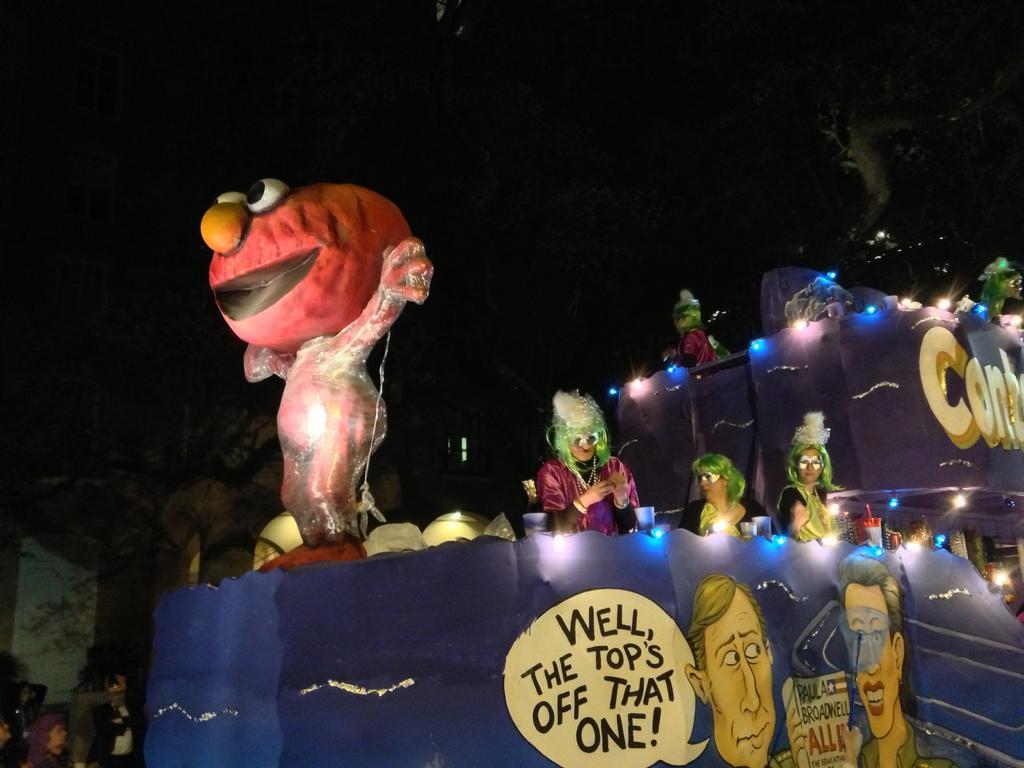Could you give a brief overview of what you see in this image? This is the picture of a place where we have some cartoons, boards on which there is something written and also I can see some lights around. 